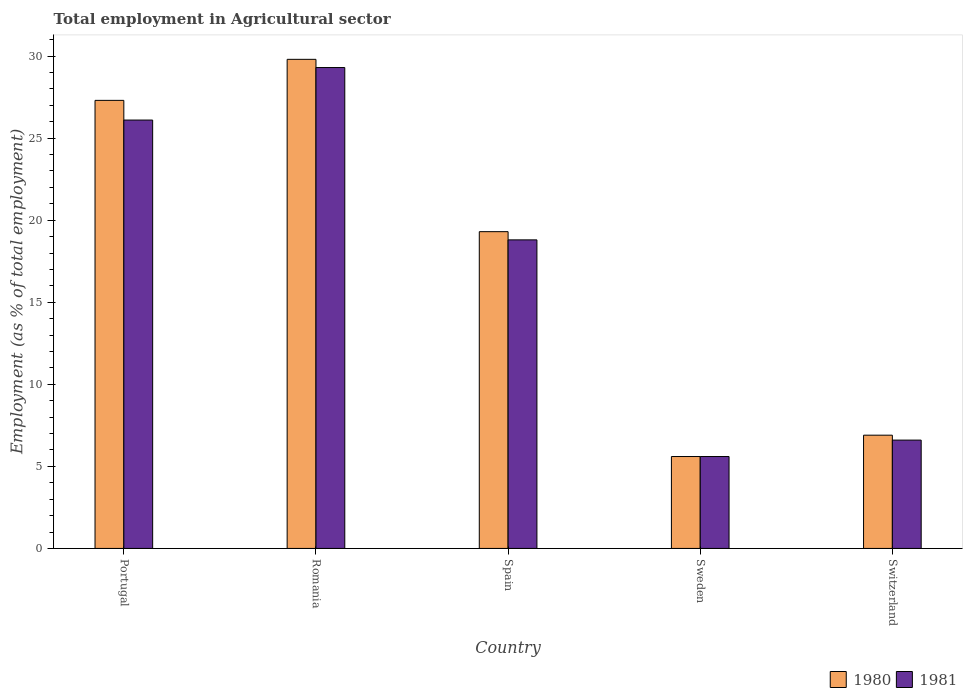How many different coloured bars are there?
Make the answer very short. 2. Are the number of bars per tick equal to the number of legend labels?
Your answer should be compact. Yes. Are the number of bars on each tick of the X-axis equal?
Ensure brevity in your answer.  Yes. How many bars are there on the 1st tick from the left?
Make the answer very short. 2. How many bars are there on the 3rd tick from the right?
Offer a very short reply. 2. What is the employment in agricultural sector in 1981 in Portugal?
Keep it short and to the point. 26.1. Across all countries, what is the maximum employment in agricultural sector in 1981?
Keep it short and to the point. 29.3. Across all countries, what is the minimum employment in agricultural sector in 1981?
Give a very brief answer. 5.6. In which country was the employment in agricultural sector in 1981 maximum?
Provide a short and direct response. Romania. In which country was the employment in agricultural sector in 1980 minimum?
Provide a succinct answer. Sweden. What is the total employment in agricultural sector in 1980 in the graph?
Your answer should be very brief. 88.9. What is the difference between the employment in agricultural sector in 1980 in Portugal and that in Romania?
Provide a short and direct response. -2.5. What is the average employment in agricultural sector in 1981 per country?
Your answer should be very brief. 17.28. What is the difference between the employment in agricultural sector of/in 1981 and employment in agricultural sector of/in 1980 in Portugal?
Make the answer very short. -1.2. What is the ratio of the employment in agricultural sector in 1980 in Spain to that in Switzerland?
Offer a very short reply. 2.8. Is the difference between the employment in agricultural sector in 1981 in Sweden and Switzerland greater than the difference between the employment in agricultural sector in 1980 in Sweden and Switzerland?
Your response must be concise. Yes. What is the difference between the highest and the second highest employment in agricultural sector in 1980?
Offer a terse response. -8. What is the difference between the highest and the lowest employment in agricultural sector in 1981?
Give a very brief answer. 23.7. In how many countries, is the employment in agricultural sector in 1981 greater than the average employment in agricultural sector in 1981 taken over all countries?
Ensure brevity in your answer.  3. What does the 2nd bar from the left in Portugal represents?
Offer a very short reply. 1981. What does the 1st bar from the right in Portugal represents?
Provide a short and direct response. 1981. How many bars are there?
Your answer should be compact. 10. How many countries are there in the graph?
Your response must be concise. 5. What is the difference between two consecutive major ticks on the Y-axis?
Provide a succinct answer. 5. Does the graph contain grids?
Offer a very short reply. No. Where does the legend appear in the graph?
Your answer should be very brief. Bottom right. How many legend labels are there?
Your answer should be compact. 2. What is the title of the graph?
Your answer should be very brief. Total employment in Agricultural sector. What is the label or title of the Y-axis?
Your answer should be compact. Employment (as % of total employment). What is the Employment (as % of total employment) of 1980 in Portugal?
Keep it short and to the point. 27.3. What is the Employment (as % of total employment) in 1981 in Portugal?
Keep it short and to the point. 26.1. What is the Employment (as % of total employment) of 1980 in Romania?
Ensure brevity in your answer.  29.8. What is the Employment (as % of total employment) of 1981 in Romania?
Make the answer very short. 29.3. What is the Employment (as % of total employment) in 1980 in Spain?
Your answer should be compact. 19.3. What is the Employment (as % of total employment) in 1981 in Spain?
Ensure brevity in your answer.  18.8. What is the Employment (as % of total employment) of 1980 in Sweden?
Give a very brief answer. 5.6. What is the Employment (as % of total employment) in 1981 in Sweden?
Give a very brief answer. 5.6. What is the Employment (as % of total employment) in 1980 in Switzerland?
Give a very brief answer. 6.9. What is the Employment (as % of total employment) in 1981 in Switzerland?
Offer a terse response. 6.6. Across all countries, what is the maximum Employment (as % of total employment) of 1980?
Offer a terse response. 29.8. Across all countries, what is the maximum Employment (as % of total employment) of 1981?
Ensure brevity in your answer.  29.3. Across all countries, what is the minimum Employment (as % of total employment) in 1980?
Make the answer very short. 5.6. Across all countries, what is the minimum Employment (as % of total employment) in 1981?
Offer a terse response. 5.6. What is the total Employment (as % of total employment) in 1980 in the graph?
Your response must be concise. 88.9. What is the total Employment (as % of total employment) of 1981 in the graph?
Keep it short and to the point. 86.4. What is the difference between the Employment (as % of total employment) of 1980 in Portugal and that in Romania?
Give a very brief answer. -2.5. What is the difference between the Employment (as % of total employment) of 1981 in Portugal and that in Spain?
Your response must be concise. 7.3. What is the difference between the Employment (as % of total employment) of 1980 in Portugal and that in Sweden?
Give a very brief answer. 21.7. What is the difference between the Employment (as % of total employment) of 1980 in Portugal and that in Switzerland?
Your answer should be compact. 20.4. What is the difference between the Employment (as % of total employment) in 1980 in Romania and that in Spain?
Your response must be concise. 10.5. What is the difference between the Employment (as % of total employment) in 1981 in Romania and that in Spain?
Ensure brevity in your answer.  10.5. What is the difference between the Employment (as % of total employment) of 1980 in Romania and that in Sweden?
Keep it short and to the point. 24.2. What is the difference between the Employment (as % of total employment) in 1981 in Romania and that in Sweden?
Provide a succinct answer. 23.7. What is the difference between the Employment (as % of total employment) in 1980 in Romania and that in Switzerland?
Your answer should be very brief. 22.9. What is the difference between the Employment (as % of total employment) of 1981 in Romania and that in Switzerland?
Offer a terse response. 22.7. What is the difference between the Employment (as % of total employment) in 1980 in Spain and that in Sweden?
Offer a terse response. 13.7. What is the difference between the Employment (as % of total employment) of 1981 in Spain and that in Sweden?
Your response must be concise. 13.2. What is the difference between the Employment (as % of total employment) of 1980 in Spain and that in Switzerland?
Keep it short and to the point. 12.4. What is the difference between the Employment (as % of total employment) of 1981 in Spain and that in Switzerland?
Make the answer very short. 12.2. What is the difference between the Employment (as % of total employment) in 1981 in Sweden and that in Switzerland?
Your answer should be compact. -1. What is the difference between the Employment (as % of total employment) of 1980 in Portugal and the Employment (as % of total employment) of 1981 in Sweden?
Offer a terse response. 21.7. What is the difference between the Employment (as % of total employment) in 1980 in Portugal and the Employment (as % of total employment) in 1981 in Switzerland?
Keep it short and to the point. 20.7. What is the difference between the Employment (as % of total employment) in 1980 in Romania and the Employment (as % of total employment) in 1981 in Sweden?
Provide a succinct answer. 24.2. What is the difference between the Employment (as % of total employment) of 1980 in Romania and the Employment (as % of total employment) of 1981 in Switzerland?
Make the answer very short. 23.2. What is the difference between the Employment (as % of total employment) in 1980 in Spain and the Employment (as % of total employment) in 1981 in Sweden?
Your answer should be very brief. 13.7. What is the difference between the Employment (as % of total employment) of 1980 in Spain and the Employment (as % of total employment) of 1981 in Switzerland?
Your answer should be compact. 12.7. What is the difference between the Employment (as % of total employment) in 1980 in Sweden and the Employment (as % of total employment) in 1981 in Switzerland?
Your answer should be compact. -1. What is the average Employment (as % of total employment) in 1980 per country?
Give a very brief answer. 17.78. What is the average Employment (as % of total employment) in 1981 per country?
Provide a succinct answer. 17.28. What is the difference between the Employment (as % of total employment) in 1980 and Employment (as % of total employment) in 1981 in Romania?
Give a very brief answer. 0.5. What is the difference between the Employment (as % of total employment) of 1980 and Employment (as % of total employment) of 1981 in Spain?
Offer a terse response. 0.5. What is the difference between the Employment (as % of total employment) of 1980 and Employment (as % of total employment) of 1981 in Sweden?
Provide a short and direct response. 0. What is the ratio of the Employment (as % of total employment) in 1980 in Portugal to that in Romania?
Provide a short and direct response. 0.92. What is the ratio of the Employment (as % of total employment) of 1981 in Portugal to that in Romania?
Give a very brief answer. 0.89. What is the ratio of the Employment (as % of total employment) of 1980 in Portugal to that in Spain?
Your answer should be compact. 1.41. What is the ratio of the Employment (as % of total employment) in 1981 in Portugal to that in Spain?
Give a very brief answer. 1.39. What is the ratio of the Employment (as % of total employment) in 1980 in Portugal to that in Sweden?
Your response must be concise. 4.88. What is the ratio of the Employment (as % of total employment) of 1981 in Portugal to that in Sweden?
Offer a terse response. 4.66. What is the ratio of the Employment (as % of total employment) of 1980 in Portugal to that in Switzerland?
Your answer should be compact. 3.96. What is the ratio of the Employment (as % of total employment) of 1981 in Portugal to that in Switzerland?
Keep it short and to the point. 3.95. What is the ratio of the Employment (as % of total employment) in 1980 in Romania to that in Spain?
Ensure brevity in your answer.  1.54. What is the ratio of the Employment (as % of total employment) of 1981 in Romania to that in Spain?
Your answer should be compact. 1.56. What is the ratio of the Employment (as % of total employment) of 1980 in Romania to that in Sweden?
Your answer should be compact. 5.32. What is the ratio of the Employment (as % of total employment) of 1981 in Romania to that in Sweden?
Your response must be concise. 5.23. What is the ratio of the Employment (as % of total employment) of 1980 in Romania to that in Switzerland?
Your response must be concise. 4.32. What is the ratio of the Employment (as % of total employment) in 1981 in Romania to that in Switzerland?
Keep it short and to the point. 4.44. What is the ratio of the Employment (as % of total employment) of 1980 in Spain to that in Sweden?
Offer a very short reply. 3.45. What is the ratio of the Employment (as % of total employment) of 1981 in Spain to that in Sweden?
Ensure brevity in your answer.  3.36. What is the ratio of the Employment (as % of total employment) in 1980 in Spain to that in Switzerland?
Provide a succinct answer. 2.8. What is the ratio of the Employment (as % of total employment) of 1981 in Spain to that in Switzerland?
Your answer should be compact. 2.85. What is the ratio of the Employment (as % of total employment) in 1980 in Sweden to that in Switzerland?
Provide a short and direct response. 0.81. What is the ratio of the Employment (as % of total employment) in 1981 in Sweden to that in Switzerland?
Your response must be concise. 0.85. What is the difference between the highest and the second highest Employment (as % of total employment) of 1980?
Your answer should be compact. 2.5. What is the difference between the highest and the second highest Employment (as % of total employment) of 1981?
Give a very brief answer. 3.2. What is the difference between the highest and the lowest Employment (as % of total employment) of 1980?
Make the answer very short. 24.2. What is the difference between the highest and the lowest Employment (as % of total employment) of 1981?
Make the answer very short. 23.7. 